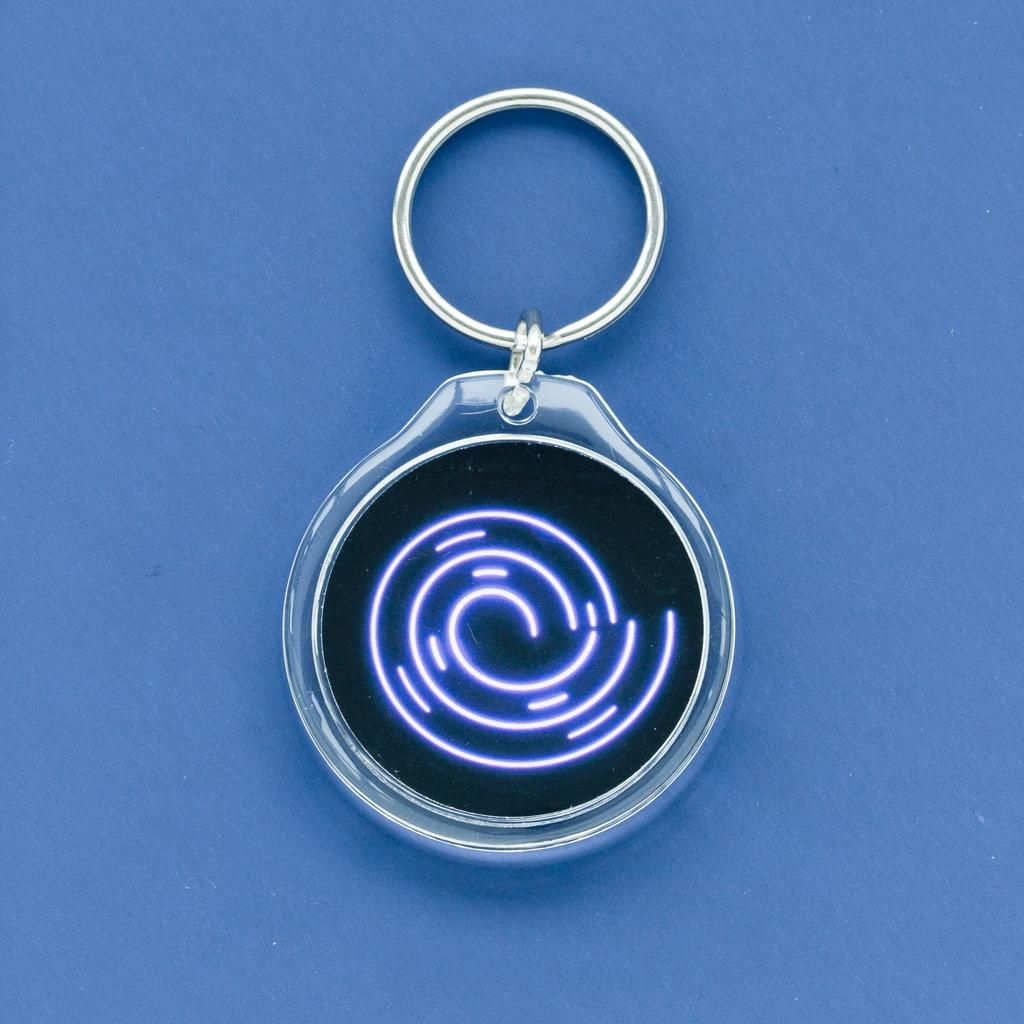What is the main subject of the image? There is a keychain in the center of the image. What type of shame can be seen on the keychain in the image? There is no shame present on the keychain in the image. 